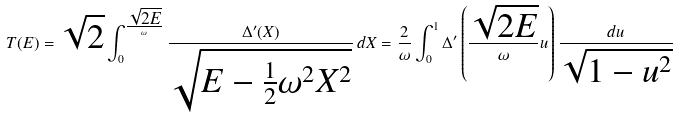<formula> <loc_0><loc_0><loc_500><loc_500>T ( E ) = \sqrt { 2 } \int _ { 0 } ^ { \frac { \sqrt { 2 E } } { \omega } } \frac { \Delta ^ { \prime } ( X ) } { \sqrt { E - \frac { 1 } { 2 } \omega ^ { 2 } X ^ { 2 } } } \, d X = \frac { 2 } { \omega } \int _ { 0 } ^ { 1 } \Delta ^ { \prime } \left ( \frac { \sqrt { 2 E } } { \omega } u \right ) \frac { d u } { \sqrt { 1 - u ^ { 2 } } }</formula> 